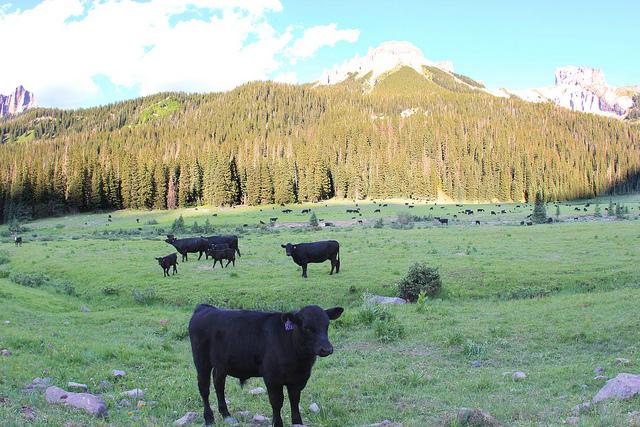What kind of environment do the cows live in?
Quick response, please. Pasture. Are there trees?
Be succinct. Yes. How many cows are there?
Quick response, please. 6. 